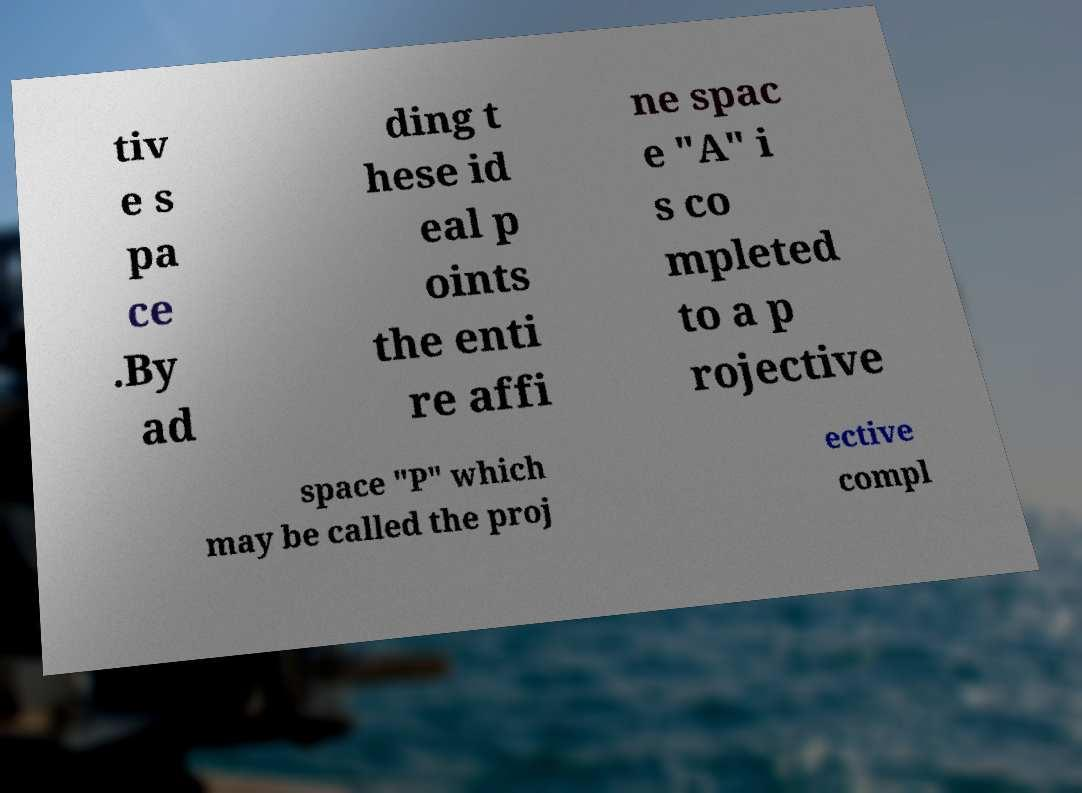What messages or text are displayed in this image? I need them in a readable, typed format. tiv e s pa ce .By ad ding t hese id eal p oints the enti re affi ne spac e "A" i s co mpleted to a p rojective space "P" which may be called the proj ective compl 